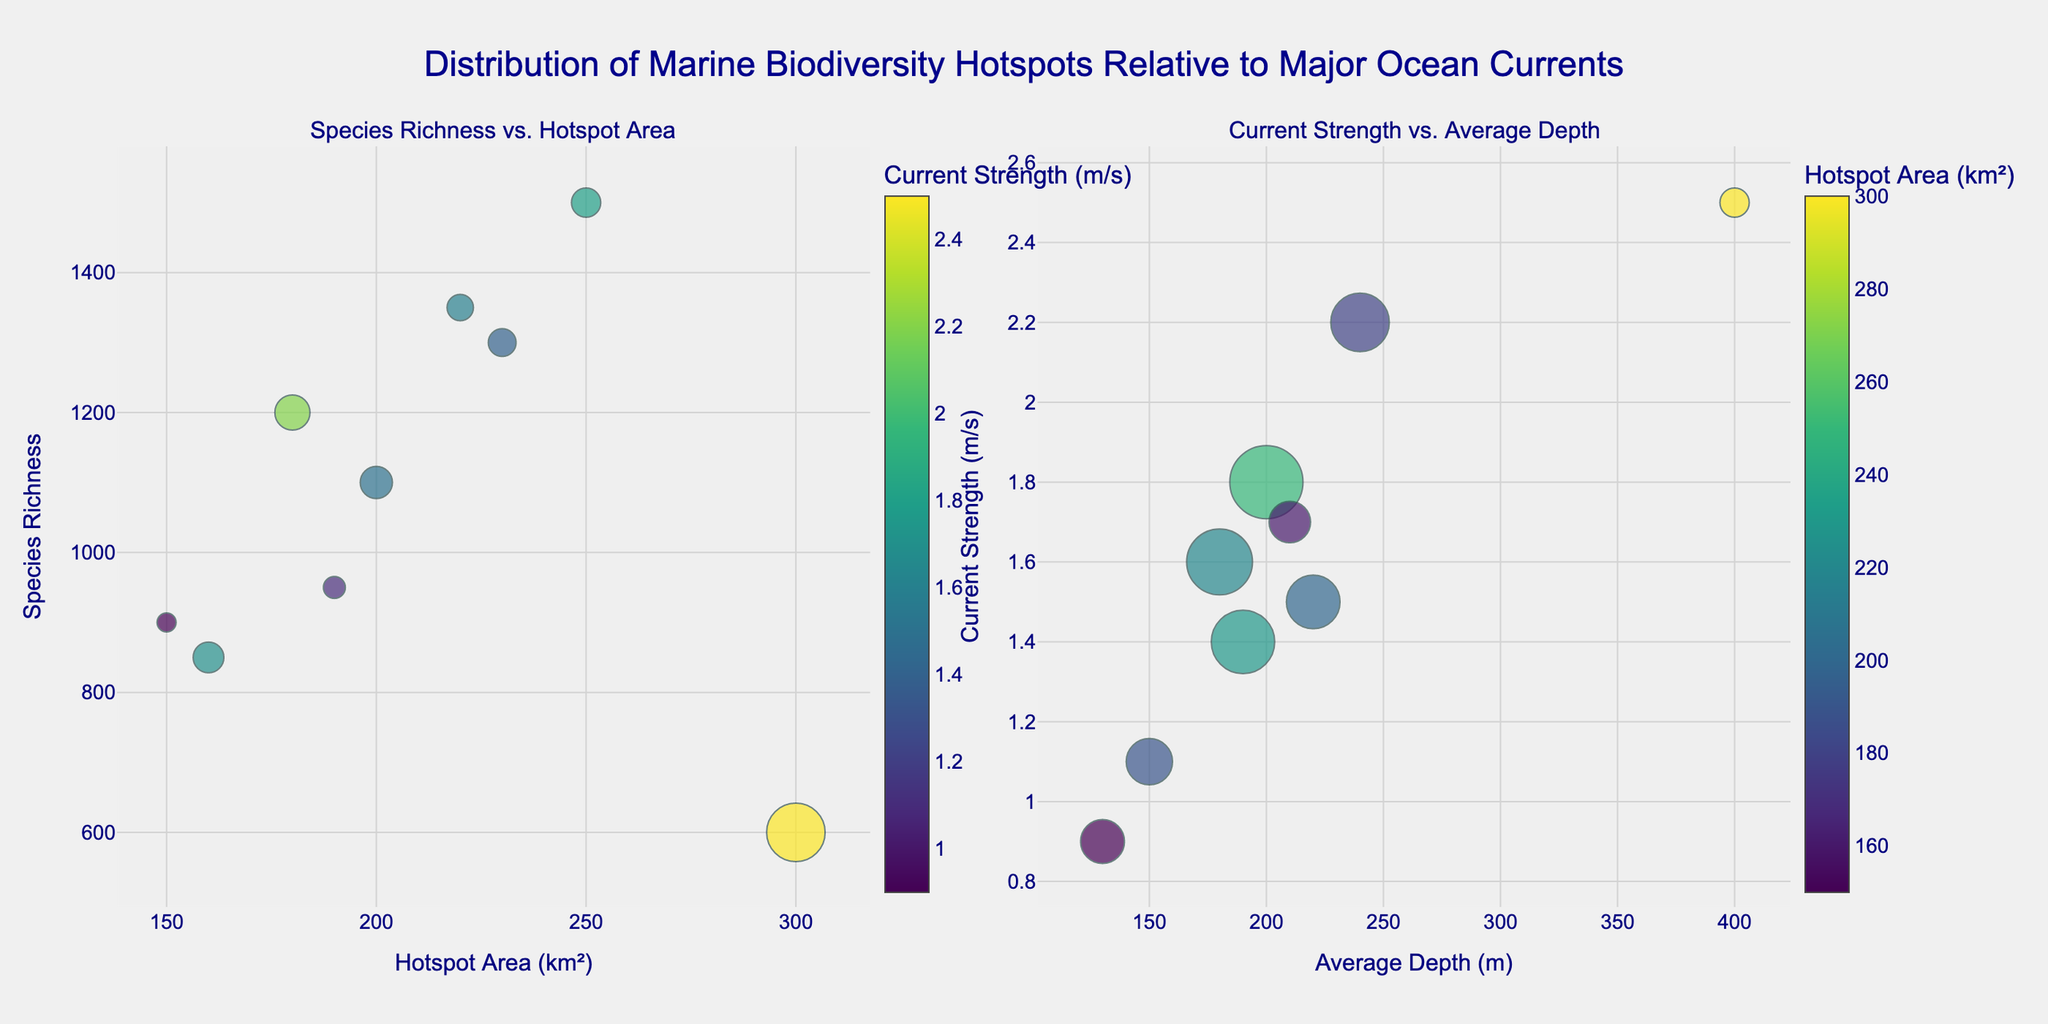what is the title of the figure? The title is usually placed at the top center of the figure. Here it reads: "Distribution of Marine Biodiversity Hotspots Relative to Major Ocean Currents"
Answer: Distribution of Marine Biodiversity Hotspots Relative to Major Ocean Currents How many data points are represented in the left subplot? The left subplot shows the data points from the Species Richness vs. Hotspot Area bubble chart. You count the number of bubbles to get the total data points, which are 9 in this case.
Answer: 9 Which ocean current is associated with the largest area hotspot? By looking at the left subplot, find the bubble farthest to the right on the x-axis (Hotspot Area). The largest area is 300 km², associated with the Antarctic Circumpolar Current.
Answer: Antarctic Circumpolar Current Which location has the highest species richness? In the left subplot, look for the bubble highest on the y-axis representing Species Richness. The highest point, which is 1500, corresponds to the North Atlantic (Gulf Stream).
Answer: North Atlantic (Gulf Stream) Is there a correlation between average depth and current strength on the right subplot? Check the right subplot to see if there's any visible trend in the scatter plot between x (Average Depth) and y (Current Strength). The points show no clear trend, making it hard to deduce a simple correlation.
Answer: No Which ocean current has the highest current strength? In the right subplot, find the bubble highest on the y-axis representing Current Strength. The highest point is 2.5 m/s associated with the Antarctic Circumpolar Current.
Answer: Antarctic Circumpolar Current What is the marker color associated with the Gulf Stream in the left subplot? The marker color represents current strength. Gulf Stream has a current strength of 1.8 m/s, which uses the Viridis color scale, indicated by a color between yellow and green.
Answer: Yellow-Green Compare species richness for ocean currents with hotspots of similar areas in the left subplot. Compare the y-values (Species Richness) of bubbles with similar x-values (Hotspot Area). For example, both the Kuroshio Current and North Atlantic Drift have similar hotspot areas around 220-230 km², but different species richness (1350 vs. 1300).
Answer: Kuroshio Current > North Atlantic Drift Does higher current strength lead to higher species richness according to the left subplot? Look at the bubbles with higher color intensity (indicating stronger current) and compare their y-values (Species Richness). No clear pattern indicates that higher current strength directly leads to higher species richness.
Answer: No 